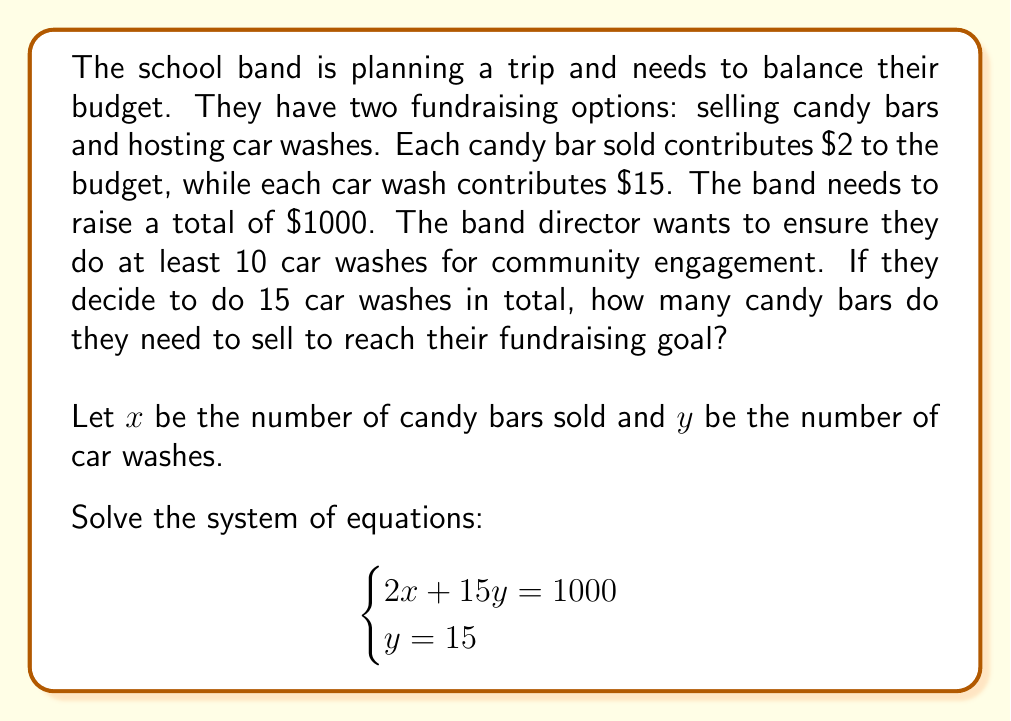Could you help me with this problem? Let's solve this system of equations step by step:

1) We're given two equations:
   $$\begin{cases}
   2x + 15y = 1000 \\
   y = 15
   \end{cases}$$

2) Since we know $y = 15$, we can substitute this into the first equation:
   $$2x + 15(15) = 1000$$

3) Simplify:
   $$2x + 225 = 1000$$

4) Subtract 225 from both sides:
   $$2x = 775$$

5) Divide both sides by 2:
   $$x = 387.5$$

6) Since we can't sell half a candy bar, we need to round up to the nearest whole number:
   $$x = 388$$

Therefore, the band needs to sell 388 candy bars along with doing 15 car washes to reach their fundraising goal of $1000.

Let's verify:
$$(388 \times $2) + (15 \times $15) = $776 + $225 = $1001$$

This slightly exceeds the goal, but it's the minimum number of whole candy bars needed.
Answer: 388 candy bars 